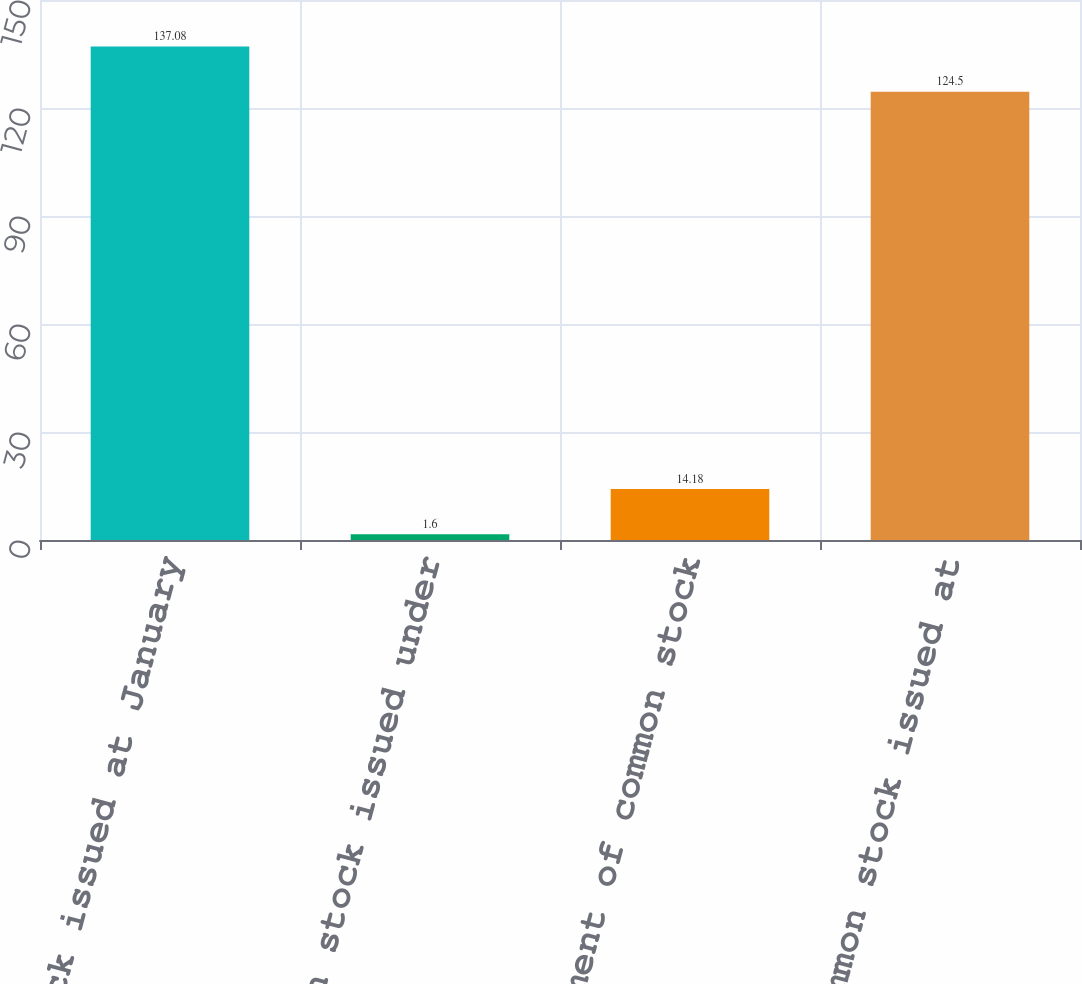<chart> <loc_0><loc_0><loc_500><loc_500><bar_chart><fcel>Common stock issued at January<fcel>Common stock issued under<fcel>Retirement of common stock<fcel>Common stock issued at<nl><fcel>137.08<fcel>1.6<fcel>14.18<fcel>124.5<nl></chart> 